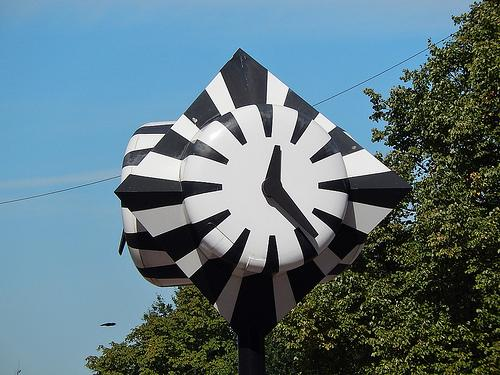Describe the primary object in the image and what it conveys at first glance. A black and white clock adorning the outdoors exhibits a modern, stylish aesthetic as it displays the time of 12:24 pm, surrounded by a clear sky and vibrant green trees. Briefly explain what dominates the scene and the background elements. A tall black and white striped clock stands outside, neighbored by clear sky and green trees, with a bird flying high. In one sentence, state the main object and a few elements around it. An outdoor black and white clock displaying 12:24 pm rests on a pole amid clear skies, green trees, and a bird soaring in the air. Mention the key elements of the image in an informal tone. Yo! There's this super cool modern black & white clock, right? It's got no digits, but it's showing 12:24 pm, and a bird's flying nearby too. Write a poetic description of the central focus of the image. Rising tall in sylvan realms, a monochrome timekeeper stands alone; Banded might, it ticks away, as a lonesome avian dances there in twilit gusts that sway. Write a refined and intellectual-style summary of the main object in the image. A contemporary, monochromatic timepiece, replete with zebra motifs, can be observed exhibiting the hour of 12:24 pm amidst its verdurous and celestial vicinity. Creatively narrate the primary subject and the ambiance in the image captured. Under a cloudless sky arching above, there stands a majestic clock adorned with zebra stripes, casting its black and white spell as it chimes 12:24 pm. Tell a friend about the primary subject of the photograph in a casual tone. Hey bud, I saw this interesting outdoor clock today; it's black and white, has stripes and no numbers, but shows 12:24 pm, not to mention the clear sky and trees around it. Summarize the primary object and its attributes that are displayed in the photograph. A modern, black and white outdoor clock situated on a pole shows 12:24 pm, has zebra stripes, and no hour numbers. Express the main focus of the image using an exclamatory remark. Wow, this striking modern clock is a unique sight to see, elegantly standing outdoors in a world of green and blue! 